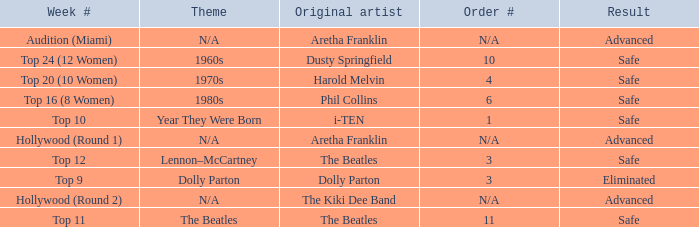What is the order number that has top 20 (10 women)  as the week number? 4.0. 